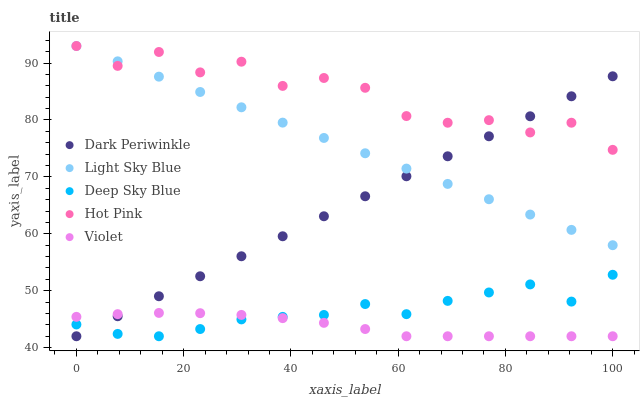Does Violet have the minimum area under the curve?
Answer yes or no. Yes. Does Hot Pink have the maximum area under the curve?
Answer yes or no. Yes. Does Light Sky Blue have the minimum area under the curve?
Answer yes or no. No. Does Light Sky Blue have the maximum area under the curve?
Answer yes or no. No. Is Light Sky Blue the smoothest?
Answer yes or no. Yes. Is Hot Pink the roughest?
Answer yes or no. Yes. Is Dark Periwinkle the smoothest?
Answer yes or no. No. Is Dark Periwinkle the roughest?
Answer yes or no. No. Does Violet have the lowest value?
Answer yes or no. Yes. Does Light Sky Blue have the lowest value?
Answer yes or no. No. Does Hot Pink have the highest value?
Answer yes or no. Yes. Does Dark Periwinkle have the highest value?
Answer yes or no. No. Is Violet less than Hot Pink?
Answer yes or no. Yes. Is Hot Pink greater than Violet?
Answer yes or no. Yes. Does Light Sky Blue intersect Dark Periwinkle?
Answer yes or no. Yes. Is Light Sky Blue less than Dark Periwinkle?
Answer yes or no. No. Is Light Sky Blue greater than Dark Periwinkle?
Answer yes or no. No. Does Violet intersect Hot Pink?
Answer yes or no. No. 